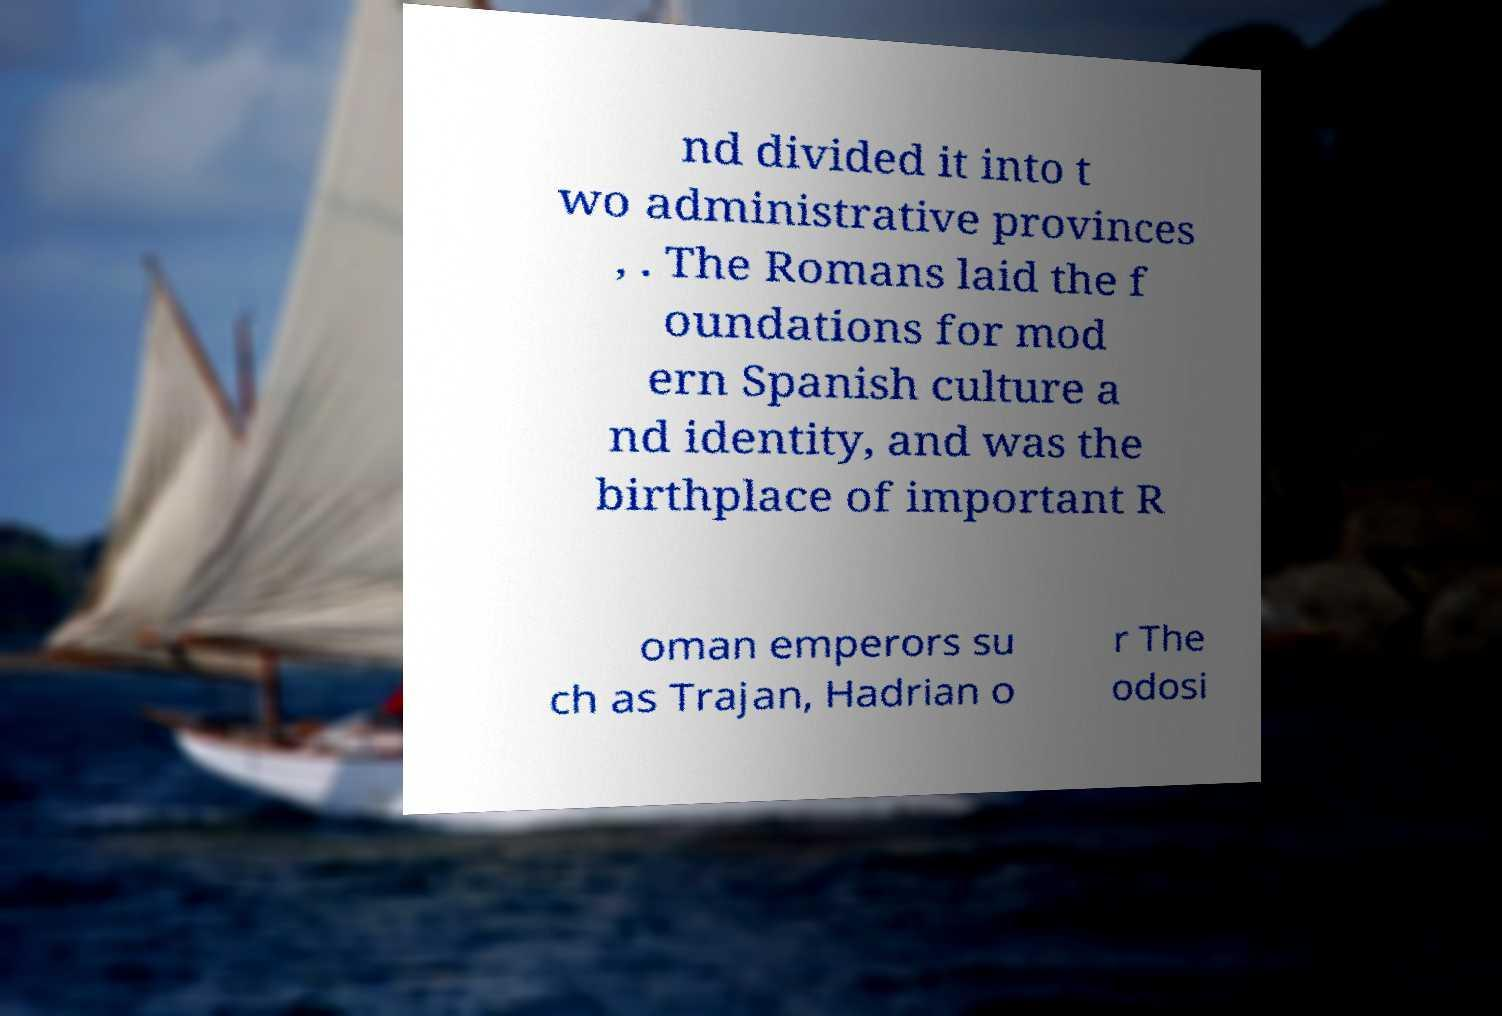Can you read and provide the text displayed in the image?This photo seems to have some interesting text. Can you extract and type it out for me? nd divided it into t wo administrative provinces , . The Romans laid the f oundations for mod ern Spanish culture a nd identity, and was the birthplace of important R oman emperors su ch as Trajan, Hadrian o r The odosi 